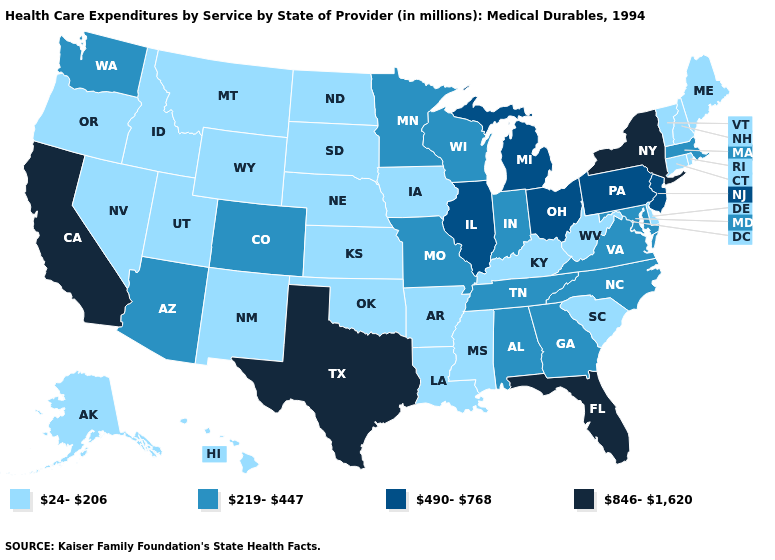Among the states that border Maryland , does Pennsylvania have the highest value?
Give a very brief answer. Yes. Name the states that have a value in the range 490-768?
Concise answer only. Illinois, Michigan, New Jersey, Ohio, Pennsylvania. Which states have the highest value in the USA?
Short answer required. California, Florida, New York, Texas. Does the map have missing data?
Write a very short answer. No. What is the value of Iowa?
Concise answer only. 24-206. Among the states that border New York , which have the highest value?
Keep it brief. New Jersey, Pennsylvania. What is the value of Tennessee?
Be succinct. 219-447. What is the value of North Carolina?
Quick response, please. 219-447. What is the lowest value in the USA?
Short answer required. 24-206. Among the states that border Vermont , which have the highest value?
Quick response, please. New York. Does Ohio have a higher value than Illinois?
Short answer required. No. Name the states that have a value in the range 490-768?
Quick response, please. Illinois, Michigan, New Jersey, Ohio, Pennsylvania. What is the value of Rhode Island?
Be succinct. 24-206. 